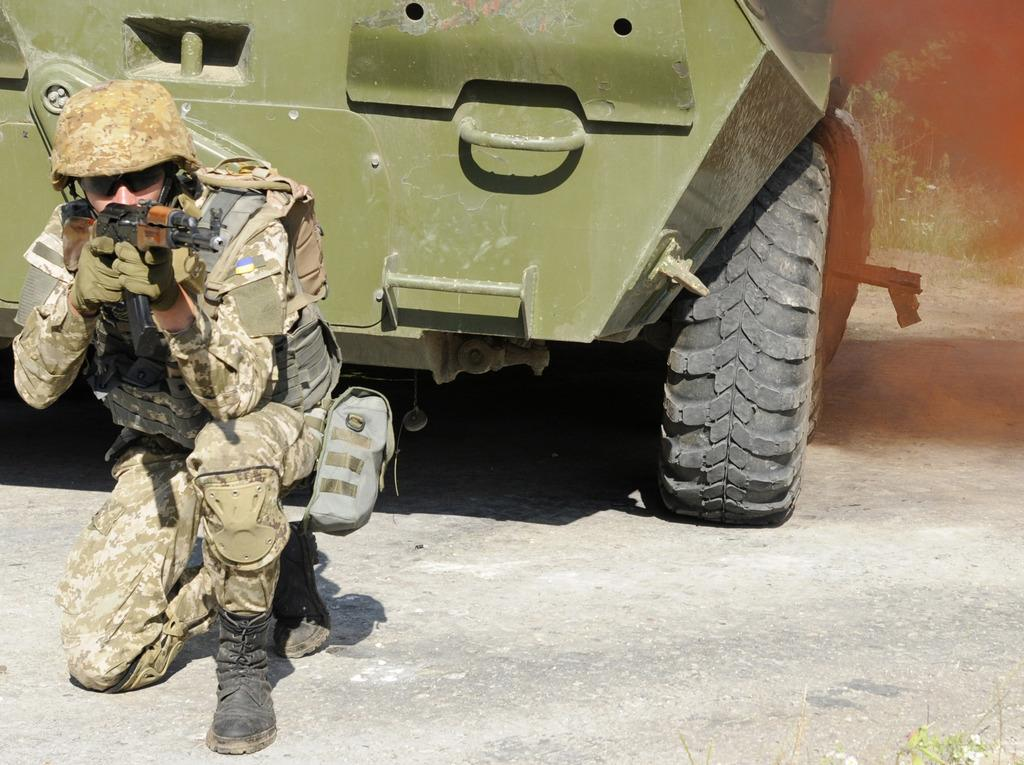Who or what is present in the image? There is a person in the image. What can be observed about the person's attire? The person is wearing clothes. What object is the person holding? The person is holding a gun. What else can be seen in the image besides the person? There is a vehicle at the top of the image. What type of jar is visible on the person's head in the image? There is no jar present on the person's head in the image. 